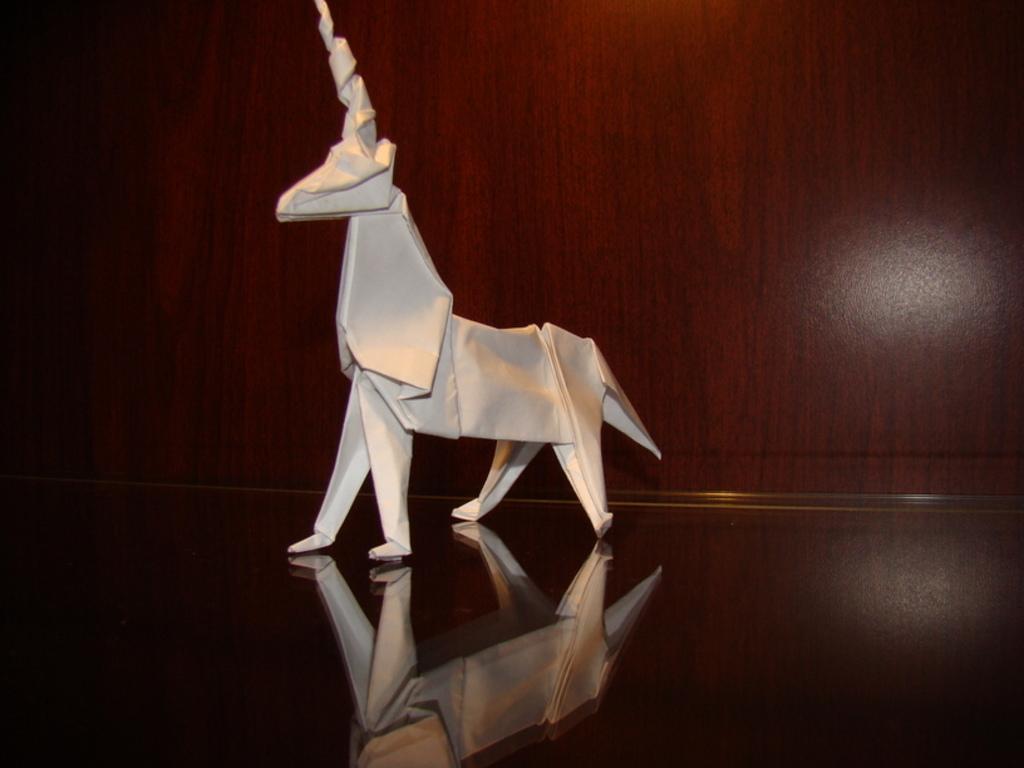Please provide a concise description of this image. In this image we can see an origami deer which is placed on the wooden surface. 